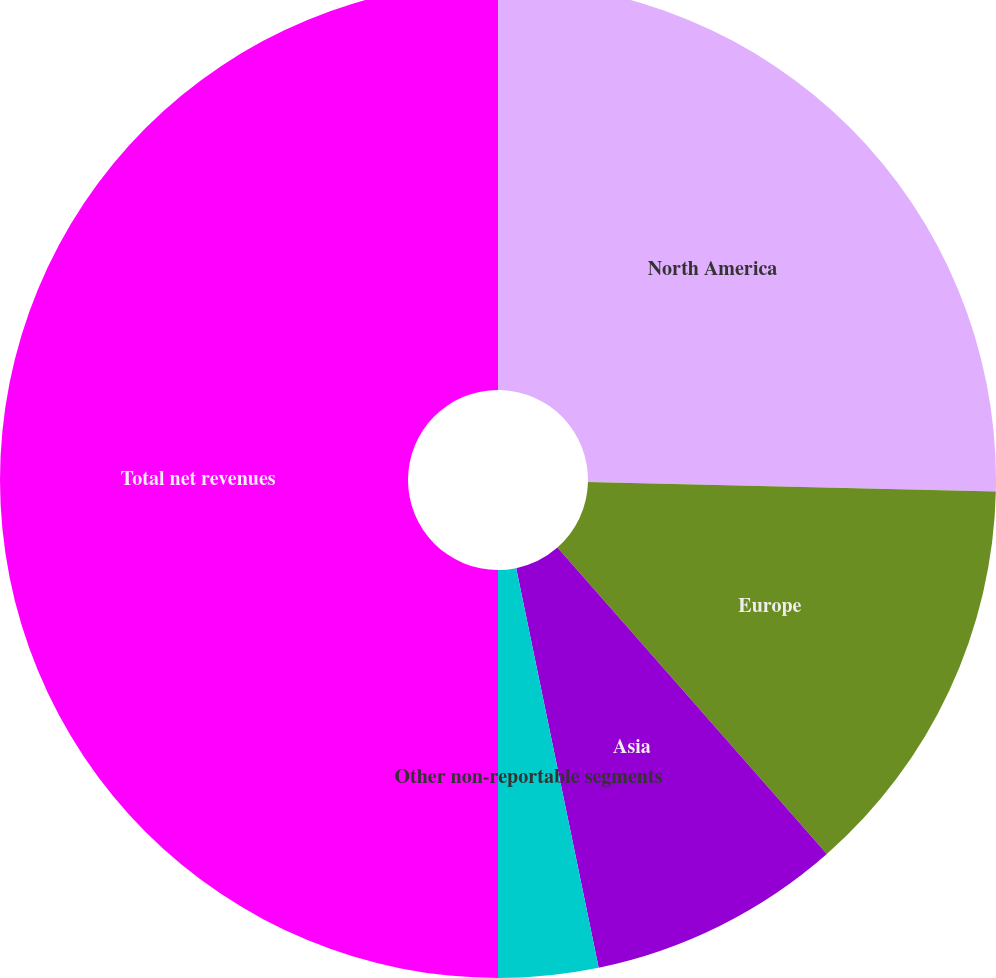<chart> <loc_0><loc_0><loc_500><loc_500><pie_chart><fcel>North America<fcel>Europe<fcel>Asia<fcel>Other non-reportable segments<fcel>Total net revenues<nl><fcel>25.37%<fcel>13.15%<fcel>8.24%<fcel>3.24%<fcel>50.0%<nl></chart> 